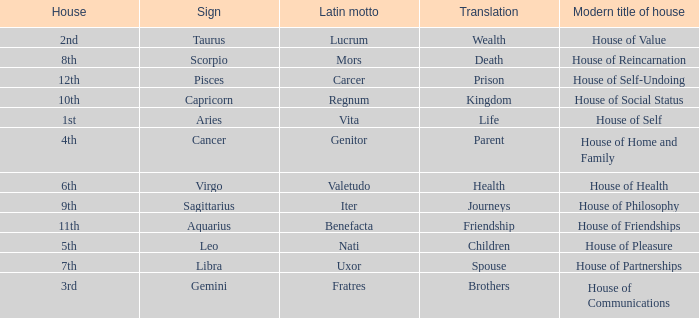What is the modern house title of the 1st house? House of Self. 